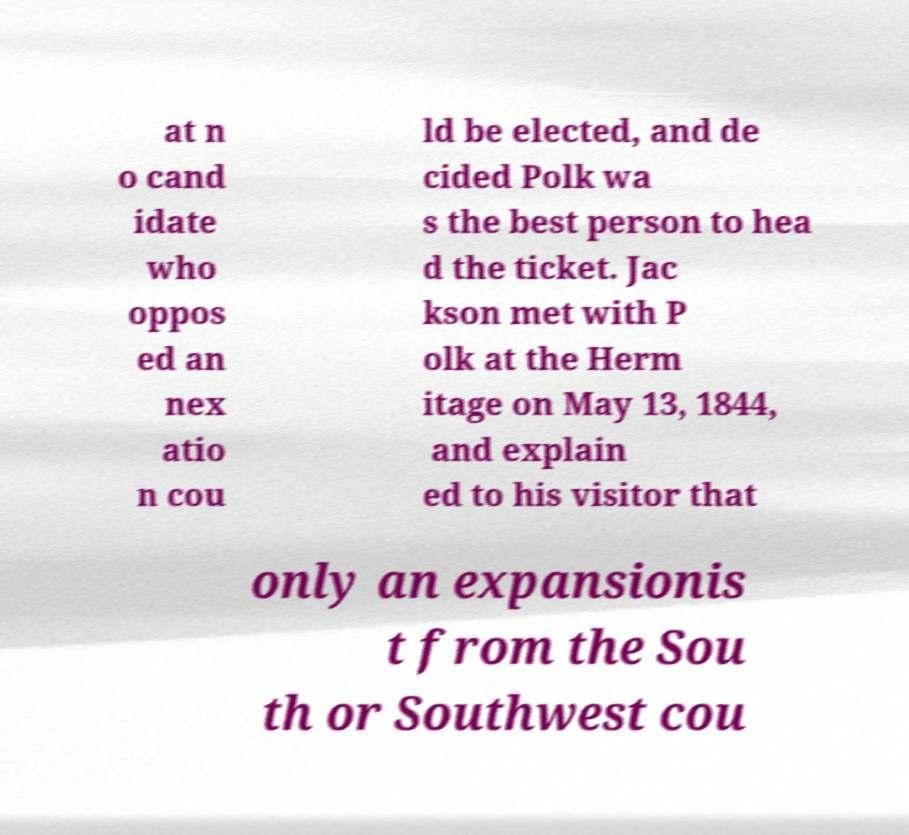Can you accurately transcribe the text from the provided image for me? at n o cand idate who oppos ed an nex atio n cou ld be elected, and de cided Polk wa s the best person to hea d the ticket. Jac kson met with P olk at the Herm itage on May 13, 1844, and explain ed to his visitor that only an expansionis t from the Sou th or Southwest cou 